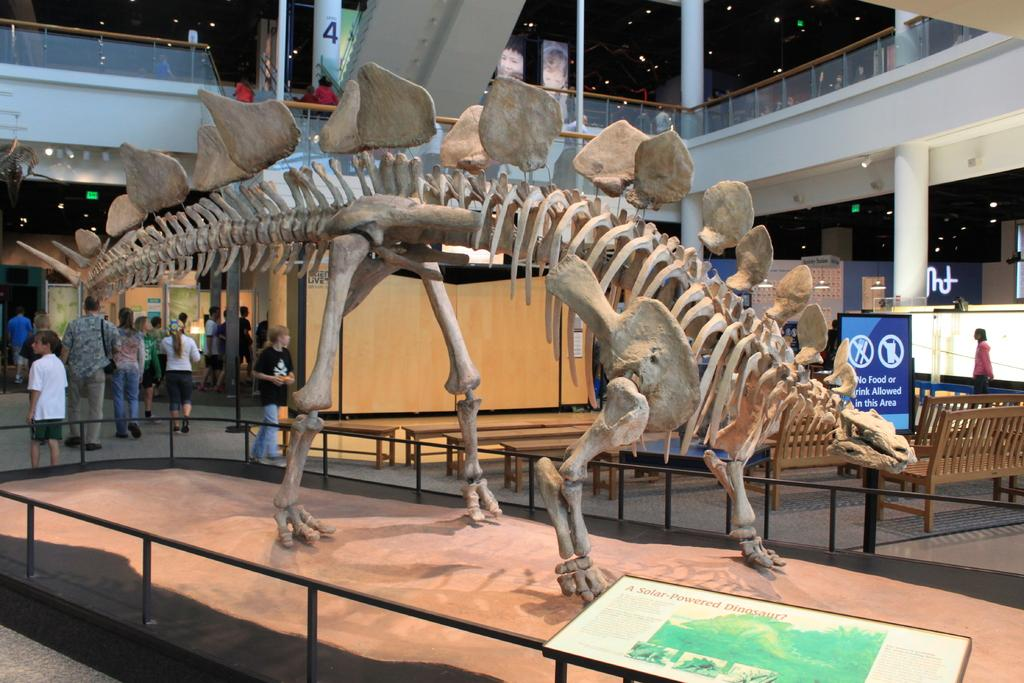What is on the table in the image? There is a skeleton of an animal on the table. Who or what can be seen in the image? There are people in the image. What architectural features are present in the image? Pillars, chairs, and benches are visible in the image. What type of lighting is present in the image? Lights are present in the image. What signs are visible in the image? Exit boards are visible in the image. What type of printed material is in the image? Posters with text are in the image. What is the owner of the hot lead doing in the image? There is no mention of hot lead or an owner in the image; the image features a skeleton of an animal on a table and other elements. 